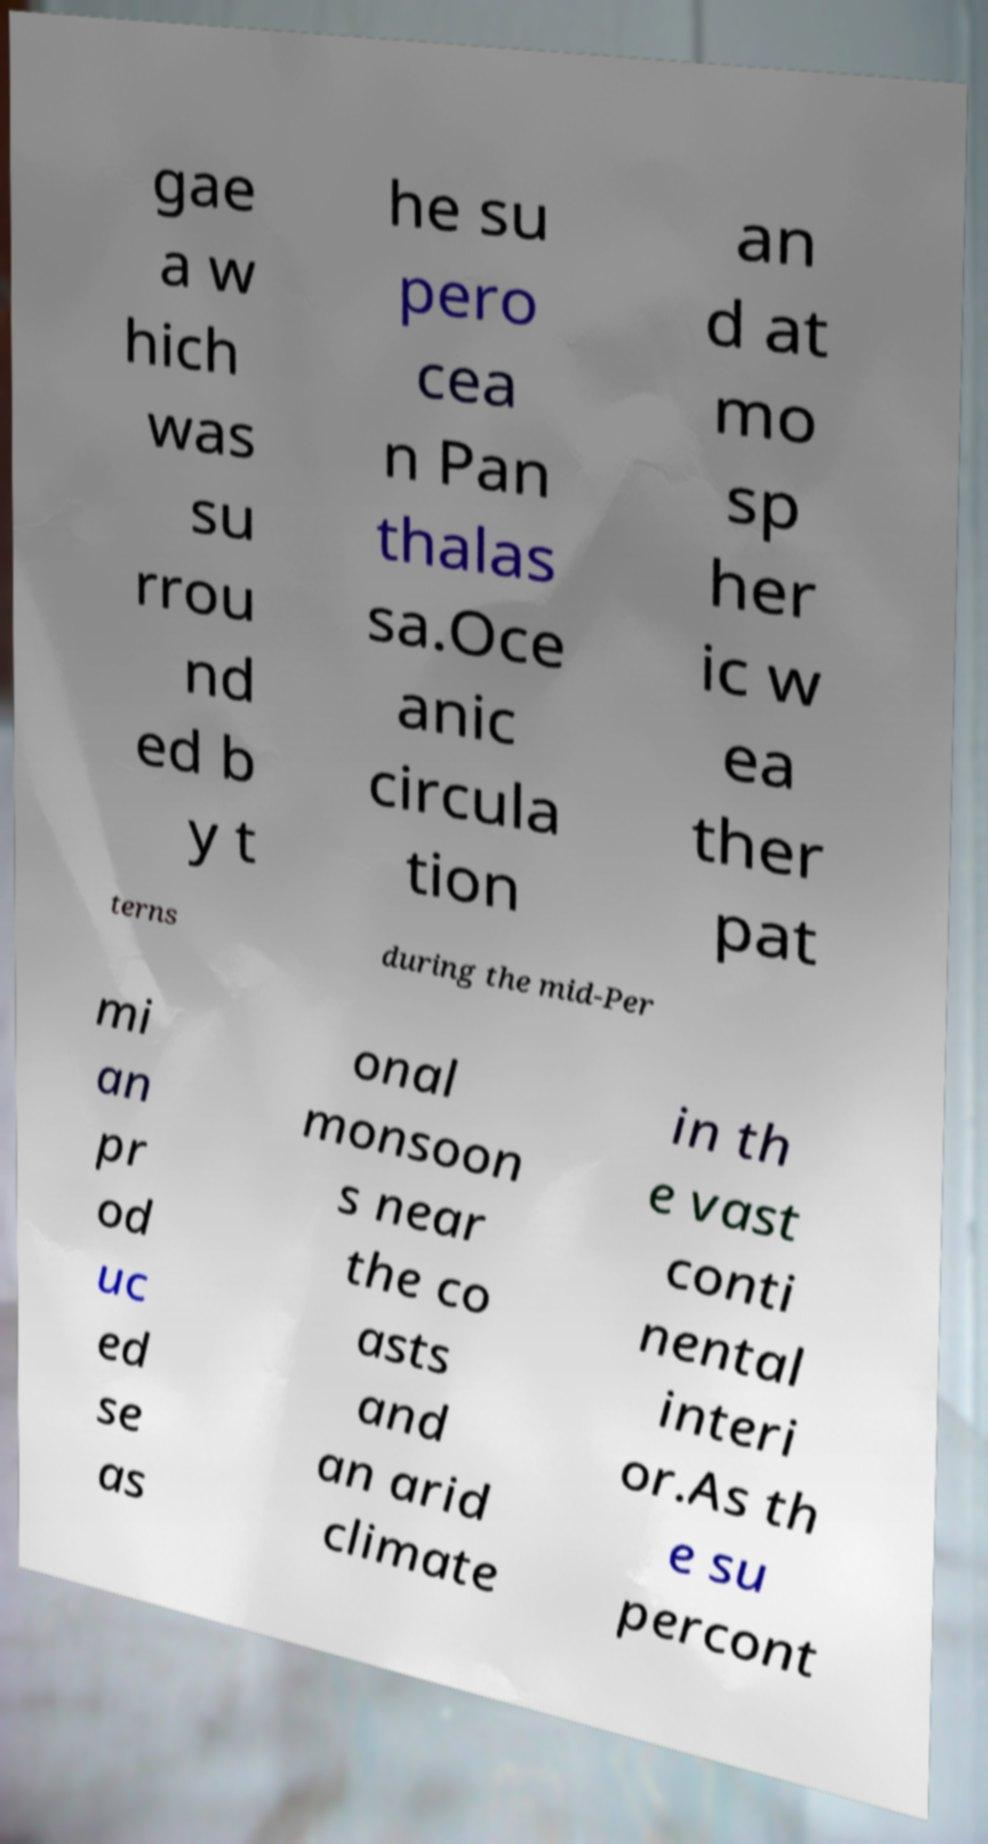Can you read and provide the text displayed in the image?This photo seems to have some interesting text. Can you extract and type it out for me? gae a w hich was su rrou nd ed b y t he su pero cea n Pan thalas sa.Oce anic circula tion an d at mo sp her ic w ea ther pat terns during the mid-Per mi an pr od uc ed se as onal monsoon s near the co asts and an arid climate in th e vast conti nental interi or.As th e su percont 